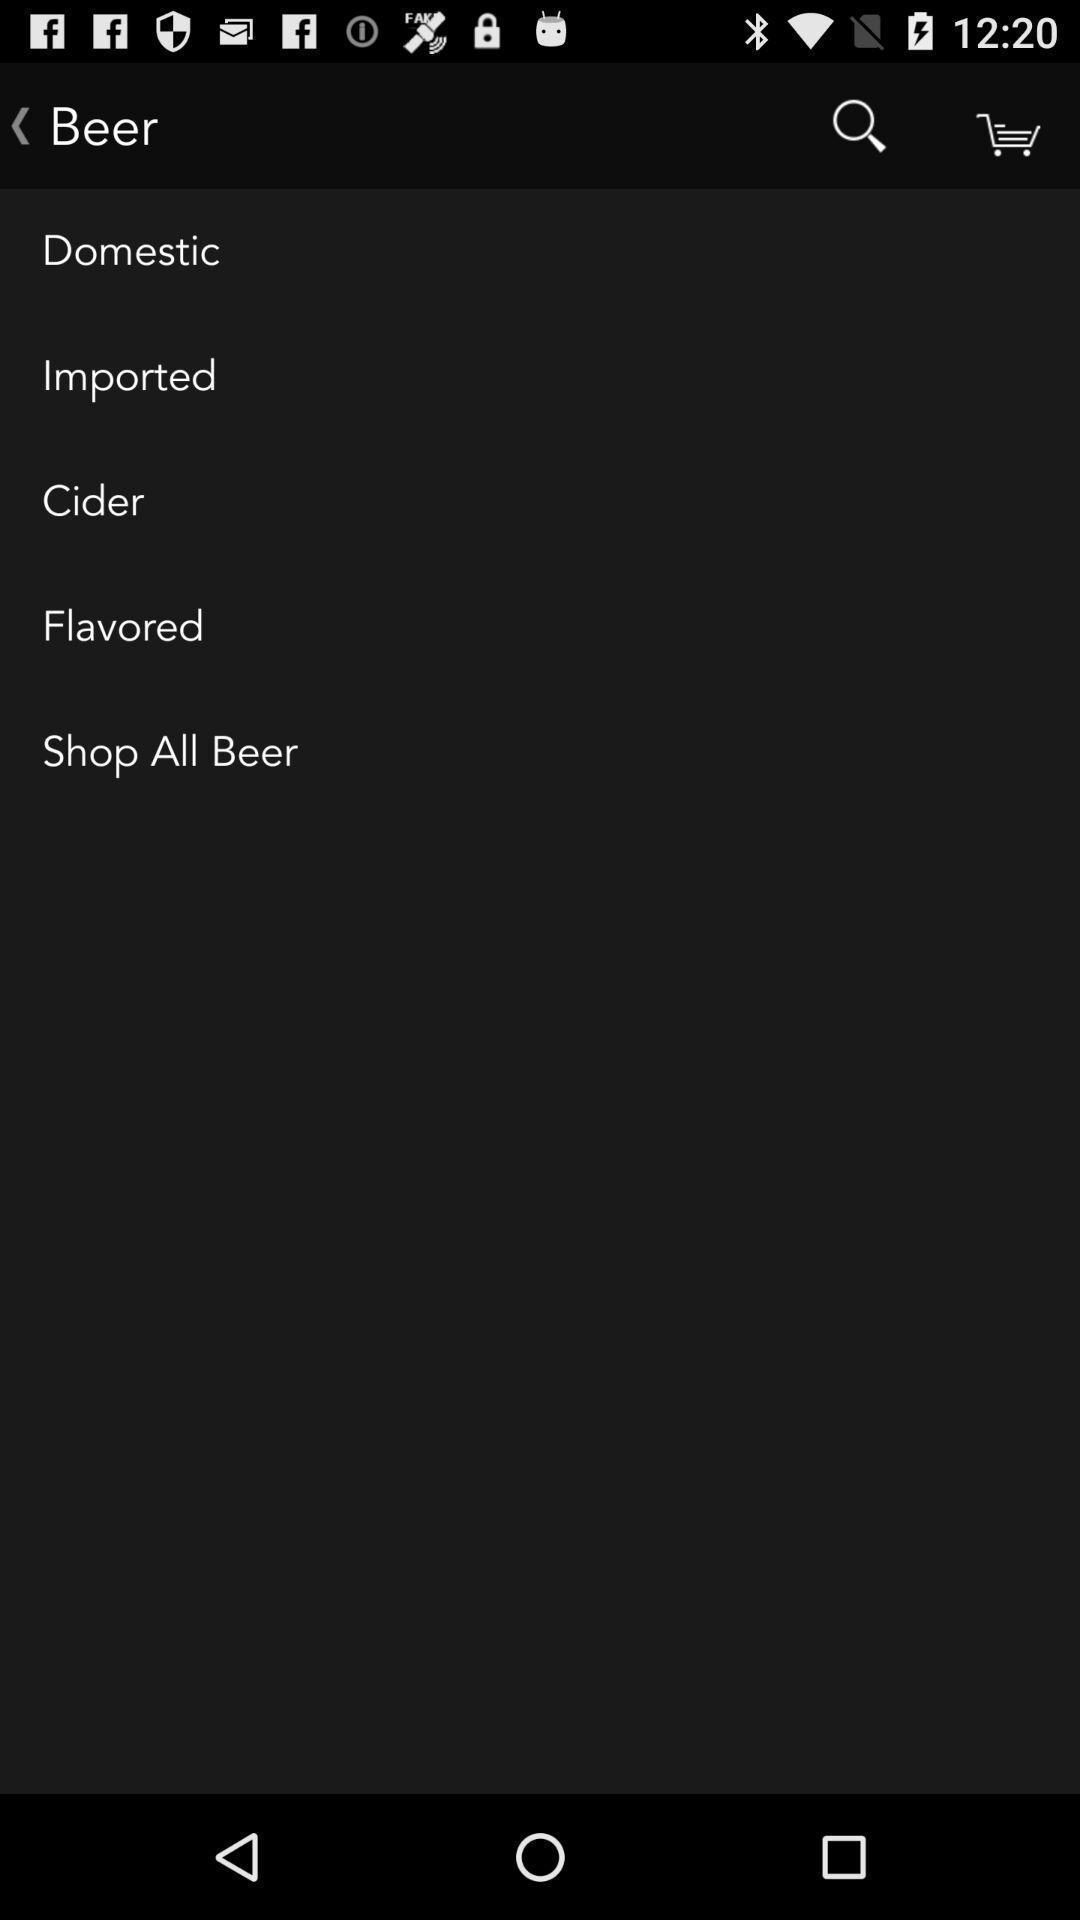Tell me what you see in this picture. Screen showing list of multiple beer categories. 